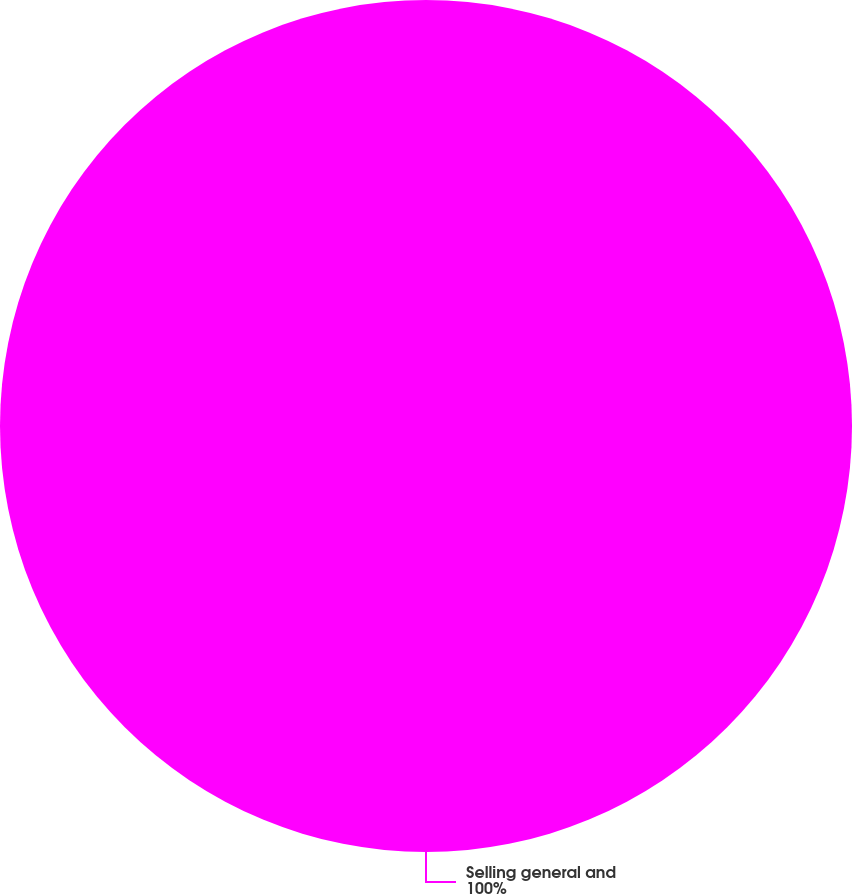<chart> <loc_0><loc_0><loc_500><loc_500><pie_chart><fcel>Selling general and<nl><fcel>100.0%<nl></chart> 